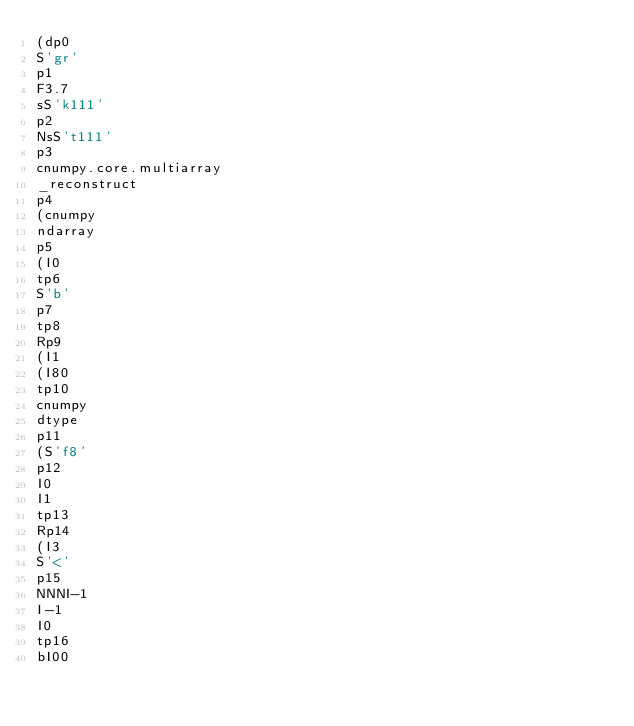Convert code to text. <code><loc_0><loc_0><loc_500><loc_500><_SQL_>(dp0
S'gr'
p1
F3.7
sS'k111'
p2
NsS't111'
p3
cnumpy.core.multiarray
_reconstruct
p4
(cnumpy
ndarray
p5
(I0
tp6
S'b'
p7
tp8
Rp9
(I1
(I80
tp10
cnumpy
dtype
p11
(S'f8'
p12
I0
I1
tp13
Rp14
(I3
S'<'
p15
NNNI-1
I-1
I0
tp16
bI00</code> 